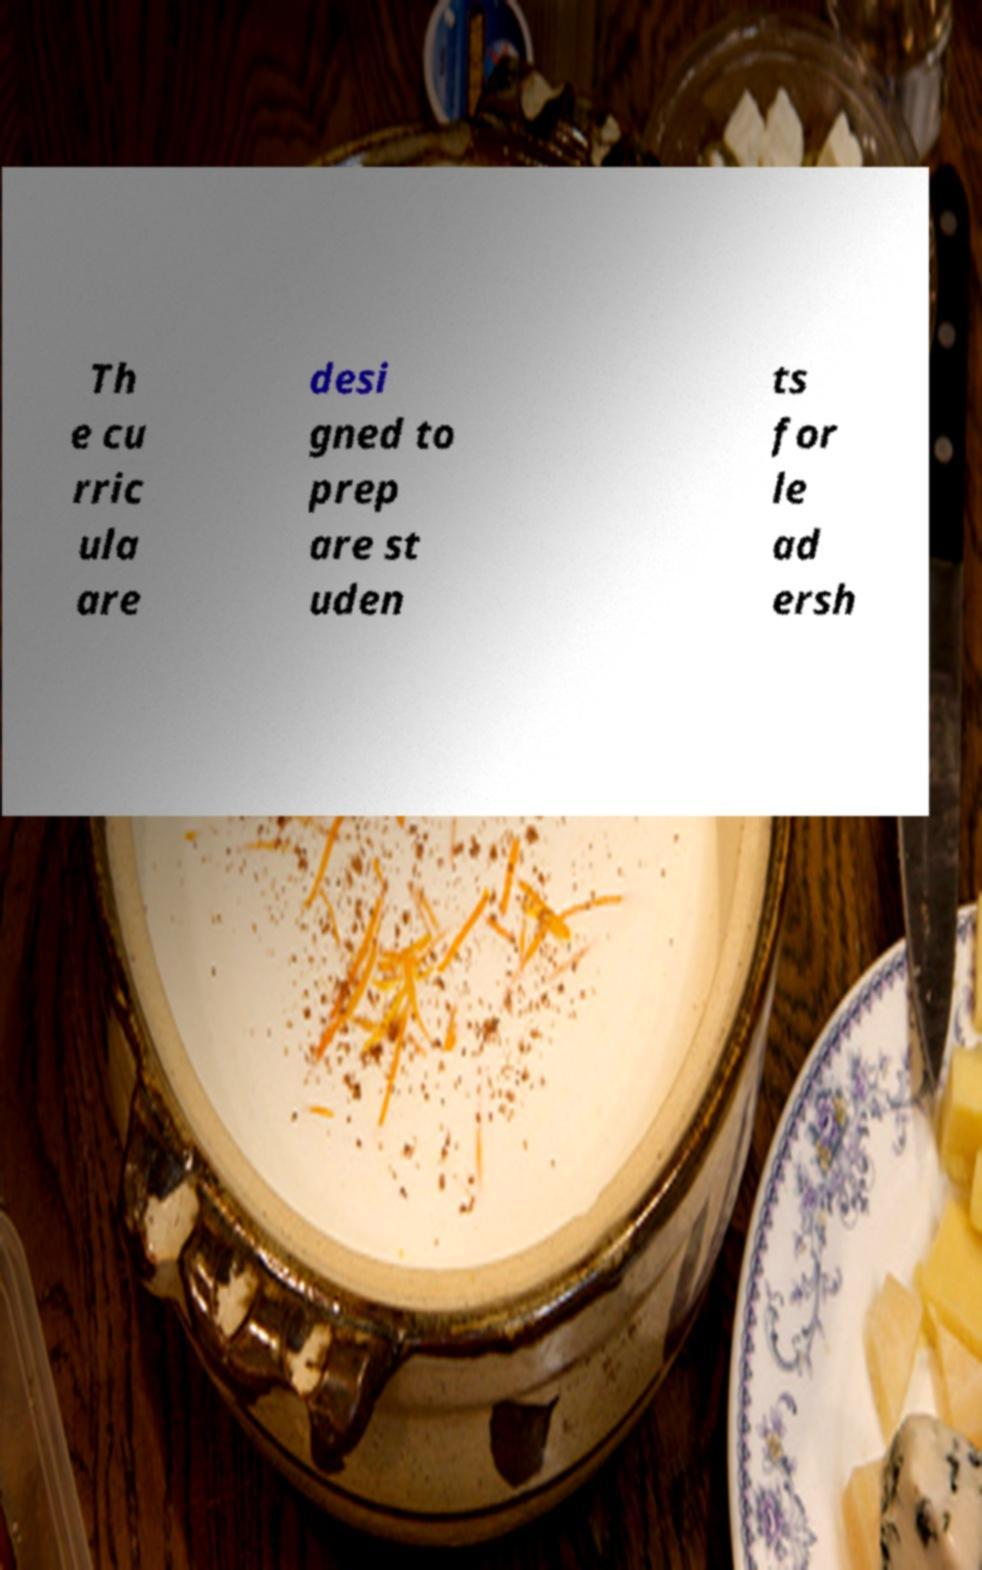Can you accurately transcribe the text from the provided image for me? Th e cu rric ula are desi gned to prep are st uden ts for le ad ersh 